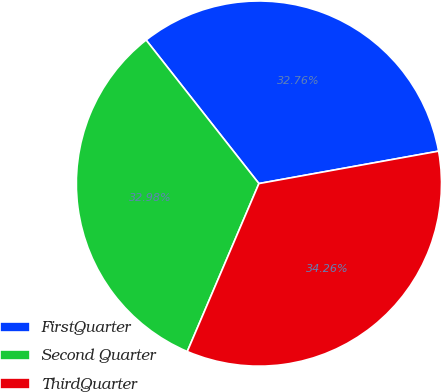<chart> <loc_0><loc_0><loc_500><loc_500><pie_chart><fcel>FirstQuarter<fcel>Second Quarter<fcel>ThirdQuarter<nl><fcel>32.76%<fcel>32.98%<fcel>34.26%<nl></chart> 